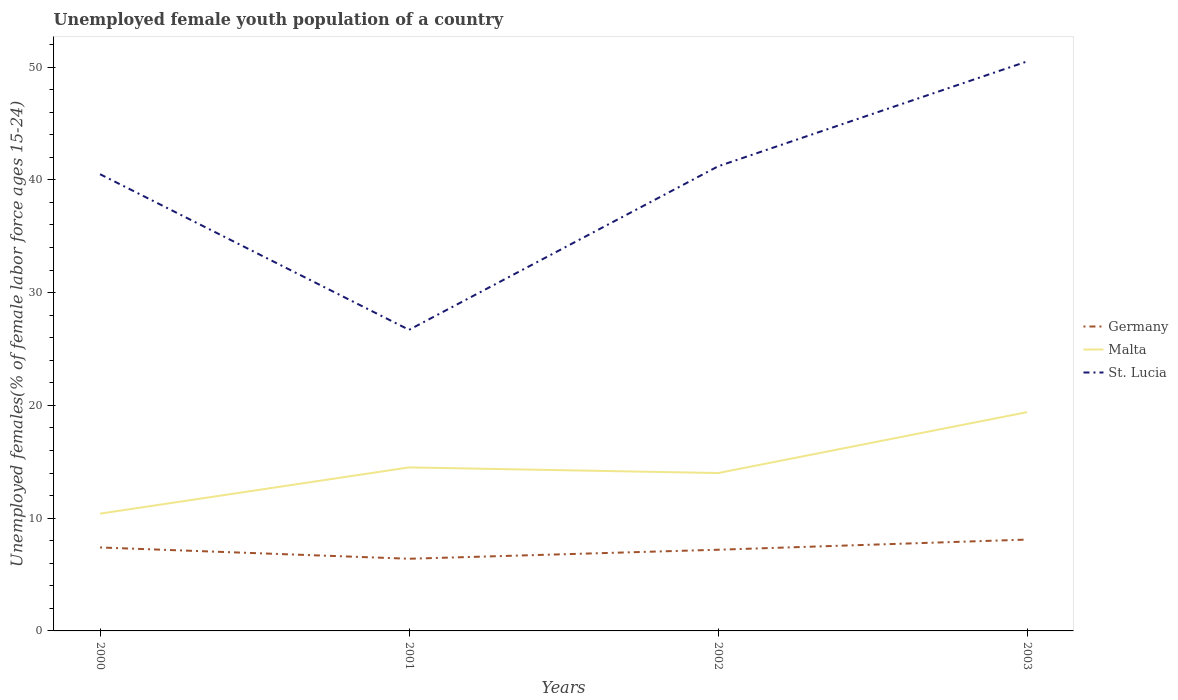Is the number of lines equal to the number of legend labels?
Offer a terse response. Yes. Across all years, what is the maximum percentage of unemployed female youth population in Malta?
Make the answer very short. 10.4. In which year was the percentage of unemployed female youth population in St. Lucia maximum?
Provide a short and direct response. 2001. What is the total percentage of unemployed female youth population in Malta in the graph?
Keep it short and to the point. -5.4. What is the difference between the highest and the second highest percentage of unemployed female youth population in Malta?
Offer a very short reply. 9. What is the difference between the highest and the lowest percentage of unemployed female youth population in Malta?
Provide a succinct answer. 1. Is the percentage of unemployed female youth population in St. Lucia strictly greater than the percentage of unemployed female youth population in Germany over the years?
Keep it short and to the point. No. How many years are there in the graph?
Provide a succinct answer. 4. Are the values on the major ticks of Y-axis written in scientific E-notation?
Offer a terse response. No. Does the graph contain grids?
Your response must be concise. No. Where does the legend appear in the graph?
Offer a very short reply. Center right. What is the title of the graph?
Your answer should be very brief. Unemployed female youth population of a country. Does "Myanmar" appear as one of the legend labels in the graph?
Keep it short and to the point. No. What is the label or title of the Y-axis?
Your answer should be very brief. Unemployed females(% of female labor force ages 15-24). What is the Unemployed females(% of female labor force ages 15-24) of Germany in 2000?
Keep it short and to the point. 7.4. What is the Unemployed females(% of female labor force ages 15-24) of Malta in 2000?
Your answer should be compact. 10.4. What is the Unemployed females(% of female labor force ages 15-24) in St. Lucia in 2000?
Ensure brevity in your answer.  40.5. What is the Unemployed females(% of female labor force ages 15-24) of Germany in 2001?
Provide a short and direct response. 6.4. What is the Unemployed females(% of female labor force ages 15-24) in St. Lucia in 2001?
Offer a very short reply. 26.7. What is the Unemployed females(% of female labor force ages 15-24) in Germany in 2002?
Keep it short and to the point. 7.2. What is the Unemployed females(% of female labor force ages 15-24) in Malta in 2002?
Your answer should be very brief. 14. What is the Unemployed females(% of female labor force ages 15-24) of St. Lucia in 2002?
Offer a very short reply. 41.2. What is the Unemployed females(% of female labor force ages 15-24) in Germany in 2003?
Make the answer very short. 8.1. What is the Unemployed females(% of female labor force ages 15-24) in Malta in 2003?
Offer a very short reply. 19.4. What is the Unemployed females(% of female labor force ages 15-24) in St. Lucia in 2003?
Offer a terse response. 50.5. Across all years, what is the maximum Unemployed females(% of female labor force ages 15-24) in Germany?
Make the answer very short. 8.1. Across all years, what is the maximum Unemployed females(% of female labor force ages 15-24) of Malta?
Your answer should be compact. 19.4. Across all years, what is the maximum Unemployed females(% of female labor force ages 15-24) of St. Lucia?
Provide a succinct answer. 50.5. Across all years, what is the minimum Unemployed females(% of female labor force ages 15-24) in Germany?
Your answer should be compact. 6.4. Across all years, what is the minimum Unemployed females(% of female labor force ages 15-24) in Malta?
Your response must be concise. 10.4. Across all years, what is the minimum Unemployed females(% of female labor force ages 15-24) of St. Lucia?
Your response must be concise. 26.7. What is the total Unemployed females(% of female labor force ages 15-24) in Germany in the graph?
Your response must be concise. 29.1. What is the total Unemployed females(% of female labor force ages 15-24) of Malta in the graph?
Your answer should be very brief. 58.3. What is the total Unemployed females(% of female labor force ages 15-24) of St. Lucia in the graph?
Ensure brevity in your answer.  158.9. What is the difference between the Unemployed females(% of female labor force ages 15-24) in Germany in 2000 and that in 2001?
Your response must be concise. 1. What is the difference between the Unemployed females(% of female labor force ages 15-24) of St. Lucia in 2000 and that in 2001?
Your answer should be very brief. 13.8. What is the difference between the Unemployed females(% of female labor force ages 15-24) of St. Lucia in 2000 and that in 2002?
Provide a succinct answer. -0.7. What is the difference between the Unemployed females(% of female labor force ages 15-24) of Malta in 2000 and that in 2003?
Keep it short and to the point. -9. What is the difference between the Unemployed females(% of female labor force ages 15-24) of Germany in 2001 and that in 2002?
Give a very brief answer. -0.8. What is the difference between the Unemployed females(% of female labor force ages 15-24) of St. Lucia in 2001 and that in 2002?
Provide a succinct answer. -14.5. What is the difference between the Unemployed females(% of female labor force ages 15-24) in Malta in 2001 and that in 2003?
Keep it short and to the point. -4.9. What is the difference between the Unemployed females(% of female labor force ages 15-24) in St. Lucia in 2001 and that in 2003?
Your answer should be compact. -23.8. What is the difference between the Unemployed females(% of female labor force ages 15-24) in Germany in 2002 and that in 2003?
Make the answer very short. -0.9. What is the difference between the Unemployed females(% of female labor force ages 15-24) of St. Lucia in 2002 and that in 2003?
Ensure brevity in your answer.  -9.3. What is the difference between the Unemployed females(% of female labor force ages 15-24) in Germany in 2000 and the Unemployed females(% of female labor force ages 15-24) in St. Lucia in 2001?
Give a very brief answer. -19.3. What is the difference between the Unemployed females(% of female labor force ages 15-24) of Malta in 2000 and the Unemployed females(% of female labor force ages 15-24) of St. Lucia in 2001?
Give a very brief answer. -16.3. What is the difference between the Unemployed females(% of female labor force ages 15-24) of Germany in 2000 and the Unemployed females(% of female labor force ages 15-24) of St. Lucia in 2002?
Make the answer very short. -33.8. What is the difference between the Unemployed females(% of female labor force ages 15-24) in Malta in 2000 and the Unemployed females(% of female labor force ages 15-24) in St. Lucia in 2002?
Your response must be concise. -30.8. What is the difference between the Unemployed females(% of female labor force ages 15-24) of Germany in 2000 and the Unemployed females(% of female labor force ages 15-24) of St. Lucia in 2003?
Provide a succinct answer. -43.1. What is the difference between the Unemployed females(% of female labor force ages 15-24) of Malta in 2000 and the Unemployed females(% of female labor force ages 15-24) of St. Lucia in 2003?
Make the answer very short. -40.1. What is the difference between the Unemployed females(% of female labor force ages 15-24) in Germany in 2001 and the Unemployed females(% of female labor force ages 15-24) in St. Lucia in 2002?
Ensure brevity in your answer.  -34.8. What is the difference between the Unemployed females(% of female labor force ages 15-24) of Malta in 2001 and the Unemployed females(% of female labor force ages 15-24) of St. Lucia in 2002?
Make the answer very short. -26.7. What is the difference between the Unemployed females(% of female labor force ages 15-24) in Germany in 2001 and the Unemployed females(% of female labor force ages 15-24) in St. Lucia in 2003?
Offer a terse response. -44.1. What is the difference between the Unemployed females(% of female labor force ages 15-24) in Malta in 2001 and the Unemployed females(% of female labor force ages 15-24) in St. Lucia in 2003?
Your response must be concise. -36. What is the difference between the Unemployed females(% of female labor force ages 15-24) of Germany in 2002 and the Unemployed females(% of female labor force ages 15-24) of Malta in 2003?
Your answer should be compact. -12.2. What is the difference between the Unemployed females(% of female labor force ages 15-24) of Germany in 2002 and the Unemployed females(% of female labor force ages 15-24) of St. Lucia in 2003?
Provide a succinct answer. -43.3. What is the difference between the Unemployed females(% of female labor force ages 15-24) in Malta in 2002 and the Unemployed females(% of female labor force ages 15-24) in St. Lucia in 2003?
Keep it short and to the point. -36.5. What is the average Unemployed females(% of female labor force ages 15-24) of Germany per year?
Offer a very short reply. 7.28. What is the average Unemployed females(% of female labor force ages 15-24) in Malta per year?
Provide a succinct answer. 14.57. What is the average Unemployed females(% of female labor force ages 15-24) of St. Lucia per year?
Provide a succinct answer. 39.73. In the year 2000, what is the difference between the Unemployed females(% of female labor force ages 15-24) in Germany and Unemployed females(% of female labor force ages 15-24) in Malta?
Offer a terse response. -3. In the year 2000, what is the difference between the Unemployed females(% of female labor force ages 15-24) of Germany and Unemployed females(% of female labor force ages 15-24) of St. Lucia?
Offer a terse response. -33.1. In the year 2000, what is the difference between the Unemployed females(% of female labor force ages 15-24) in Malta and Unemployed females(% of female labor force ages 15-24) in St. Lucia?
Provide a short and direct response. -30.1. In the year 2001, what is the difference between the Unemployed females(% of female labor force ages 15-24) in Germany and Unemployed females(% of female labor force ages 15-24) in Malta?
Keep it short and to the point. -8.1. In the year 2001, what is the difference between the Unemployed females(% of female labor force ages 15-24) in Germany and Unemployed females(% of female labor force ages 15-24) in St. Lucia?
Your answer should be very brief. -20.3. In the year 2002, what is the difference between the Unemployed females(% of female labor force ages 15-24) in Germany and Unemployed females(% of female labor force ages 15-24) in Malta?
Make the answer very short. -6.8. In the year 2002, what is the difference between the Unemployed females(% of female labor force ages 15-24) of Germany and Unemployed females(% of female labor force ages 15-24) of St. Lucia?
Your answer should be very brief. -34. In the year 2002, what is the difference between the Unemployed females(% of female labor force ages 15-24) in Malta and Unemployed females(% of female labor force ages 15-24) in St. Lucia?
Ensure brevity in your answer.  -27.2. In the year 2003, what is the difference between the Unemployed females(% of female labor force ages 15-24) of Germany and Unemployed females(% of female labor force ages 15-24) of St. Lucia?
Your response must be concise. -42.4. In the year 2003, what is the difference between the Unemployed females(% of female labor force ages 15-24) of Malta and Unemployed females(% of female labor force ages 15-24) of St. Lucia?
Make the answer very short. -31.1. What is the ratio of the Unemployed females(% of female labor force ages 15-24) in Germany in 2000 to that in 2001?
Give a very brief answer. 1.16. What is the ratio of the Unemployed females(% of female labor force ages 15-24) of Malta in 2000 to that in 2001?
Make the answer very short. 0.72. What is the ratio of the Unemployed females(% of female labor force ages 15-24) of St. Lucia in 2000 to that in 2001?
Make the answer very short. 1.52. What is the ratio of the Unemployed females(% of female labor force ages 15-24) in Germany in 2000 to that in 2002?
Keep it short and to the point. 1.03. What is the ratio of the Unemployed females(% of female labor force ages 15-24) of Malta in 2000 to that in 2002?
Give a very brief answer. 0.74. What is the ratio of the Unemployed females(% of female labor force ages 15-24) of Germany in 2000 to that in 2003?
Provide a succinct answer. 0.91. What is the ratio of the Unemployed females(% of female labor force ages 15-24) in Malta in 2000 to that in 2003?
Your response must be concise. 0.54. What is the ratio of the Unemployed females(% of female labor force ages 15-24) of St. Lucia in 2000 to that in 2003?
Ensure brevity in your answer.  0.8. What is the ratio of the Unemployed females(% of female labor force ages 15-24) in Malta in 2001 to that in 2002?
Keep it short and to the point. 1.04. What is the ratio of the Unemployed females(% of female labor force ages 15-24) of St. Lucia in 2001 to that in 2002?
Your answer should be very brief. 0.65. What is the ratio of the Unemployed females(% of female labor force ages 15-24) of Germany in 2001 to that in 2003?
Your answer should be very brief. 0.79. What is the ratio of the Unemployed females(% of female labor force ages 15-24) of Malta in 2001 to that in 2003?
Your response must be concise. 0.75. What is the ratio of the Unemployed females(% of female labor force ages 15-24) of St. Lucia in 2001 to that in 2003?
Make the answer very short. 0.53. What is the ratio of the Unemployed females(% of female labor force ages 15-24) of Germany in 2002 to that in 2003?
Your answer should be compact. 0.89. What is the ratio of the Unemployed females(% of female labor force ages 15-24) of Malta in 2002 to that in 2003?
Keep it short and to the point. 0.72. What is the ratio of the Unemployed females(% of female labor force ages 15-24) in St. Lucia in 2002 to that in 2003?
Give a very brief answer. 0.82. What is the difference between the highest and the second highest Unemployed females(% of female labor force ages 15-24) in Malta?
Your answer should be very brief. 4.9. What is the difference between the highest and the lowest Unemployed females(% of female labor force ages 15-24) in St. Lucia?
Offer a terse response. 23.8. 